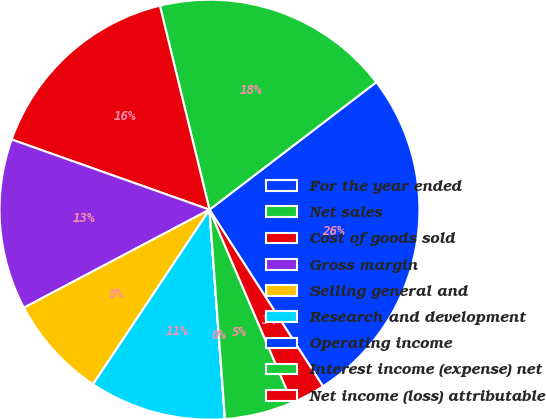Convert chart. <chart><loc_0><loc_0><loc_500><loc_500><pie_chart><fcel>For the year ended<fcel>Net sales<fcel>Cost of goods sold<fcel>Gross margin<fcel>Selling general and<fcel>Research and development<fcel>Operating income<fcel>Interest income (expense) net<fcel>Net income (loss) attributable<nl><fcel>26.3%<fcel>18.41%<fcel>15.78%<fcel>13.16%<fcel>7.9%<fcel>10.53%<fcel>0.01%<fcel>5.27%<fcel>2.64%<nl></chart> 